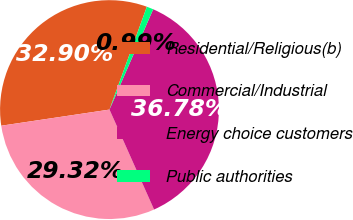<chart> <loc_0><loc_0><loc_500><loc_500><pie_chart><fcel>Residential/Religious(b)<fcel>Commercial/Industrial<fcel>Energy choice customers<fcel>Public authorities<nl><fcel>32.9%<fcel>29.32%<fcel>36.78%<fcel>0.99%<nl></chart> 